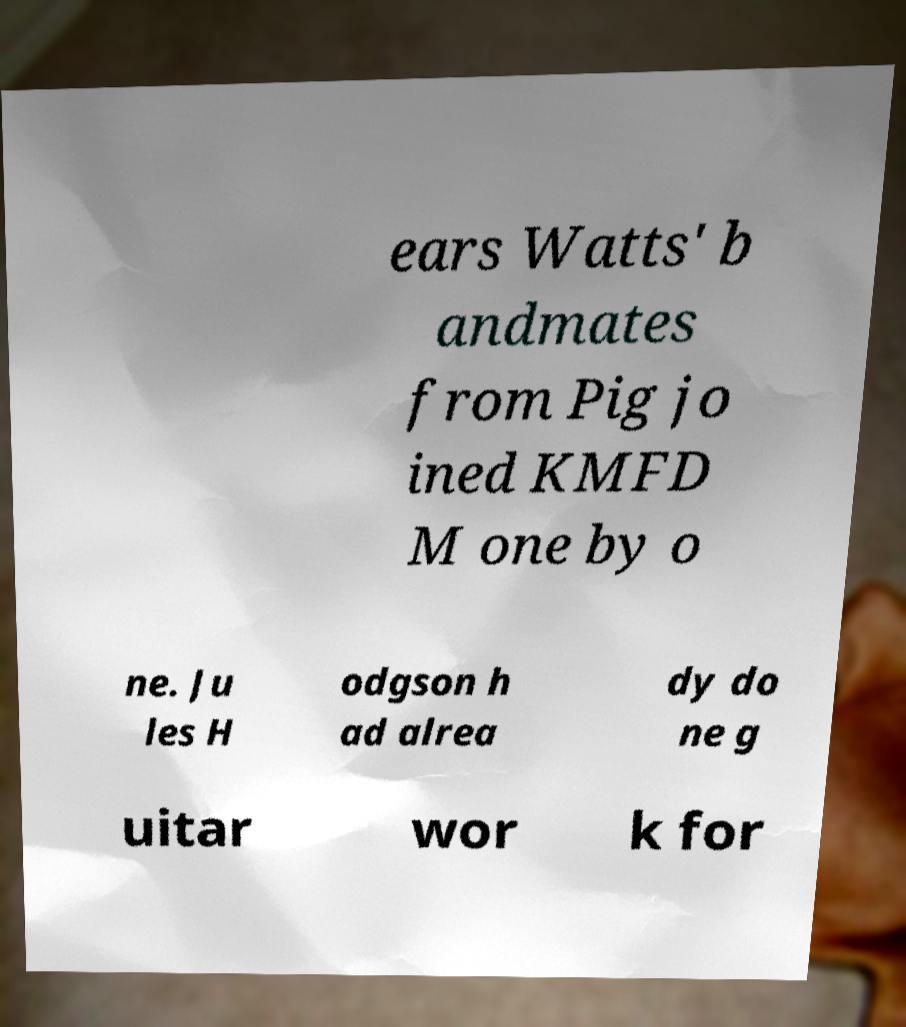For documentation purposes, I need the text within this image transcribed. Could you provide that? ears Watts' b andmates from Pig jo ined KMFD M one by o ne. Ju les H odgson h ad alrea dy do ne g uitar wor k for 